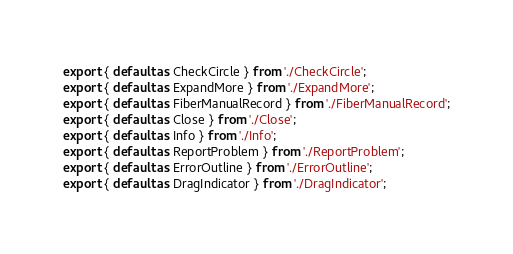<code> <loc_0><loc_0><loc_500><loc_500><_TypeScript_>export { default as CheckCircle } from './CheckCircle';
export { default as ExpandMore } from './ExpandMore';
export { default as FiberManualRecord } from './FiberManualRecord';
export { default as Close } from './Close';
export { default as Info } from './Info';
export { default as ReportProblem } from './ReportProblem';
export { default as ErrorOutline } from './ErrorOutline';
export { default as DragIndicator } from './DragIndicator';
</code> 